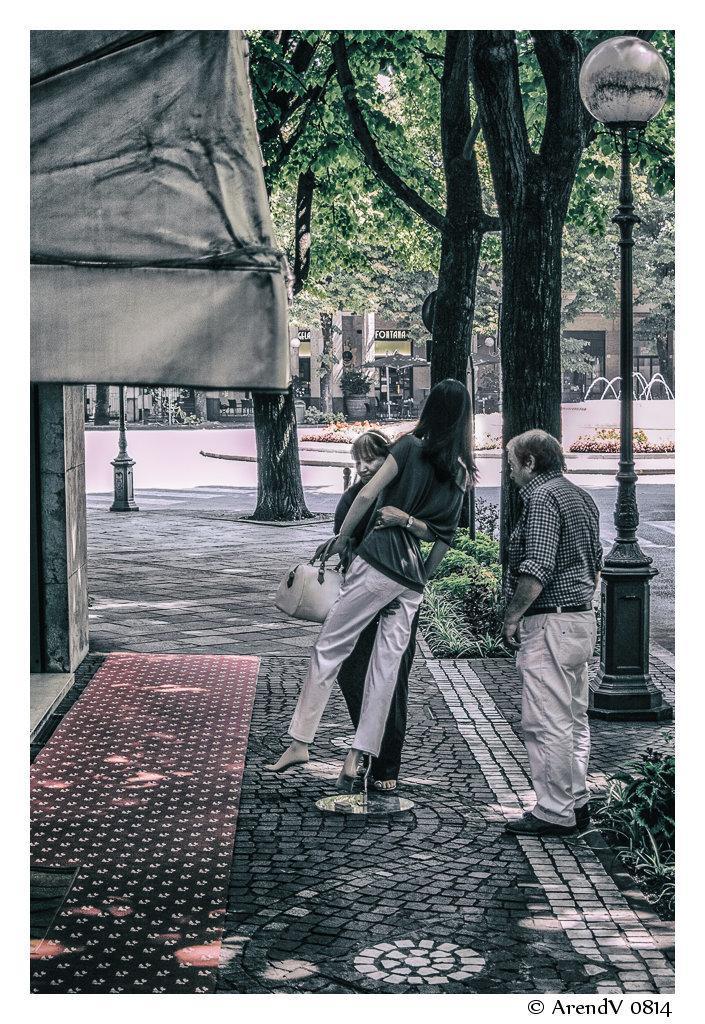Could you give a brief overview of what you see in this image? This image consists of two persons and a mannequin. The woman is holding the mannequin. At the bottom, there is road. To the left, there is a shop. In the background, there are trees. 